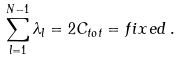<formula> <loc_0><loc_0><loc_500><loc_500>\sum _ { l = 1 } ^ { N - 1 } \lambda _ { l } = 2 C _ { t o t } = f i x e d \, .</formula> 